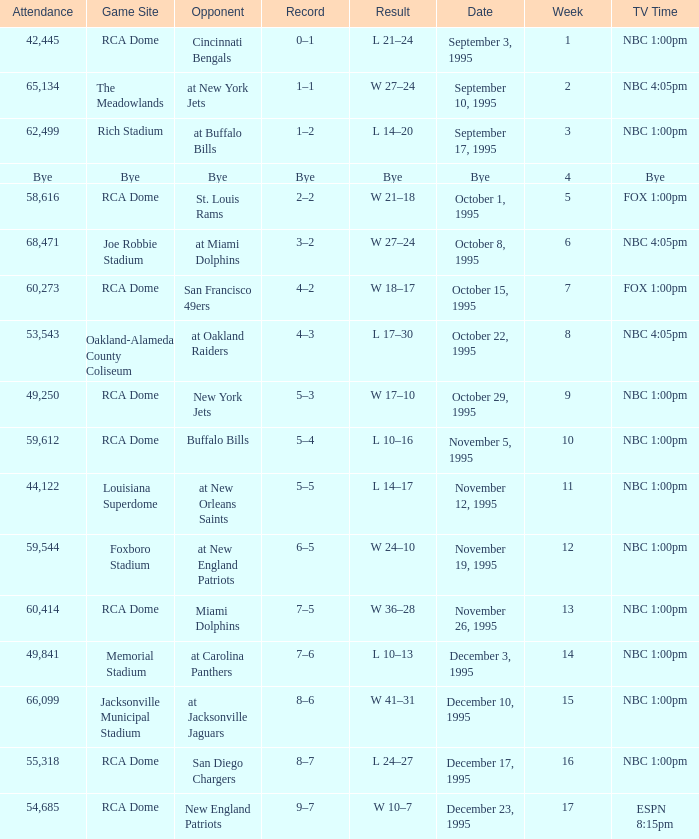What's the Opponent with a Week that's larger than 16? New England Patriots. 